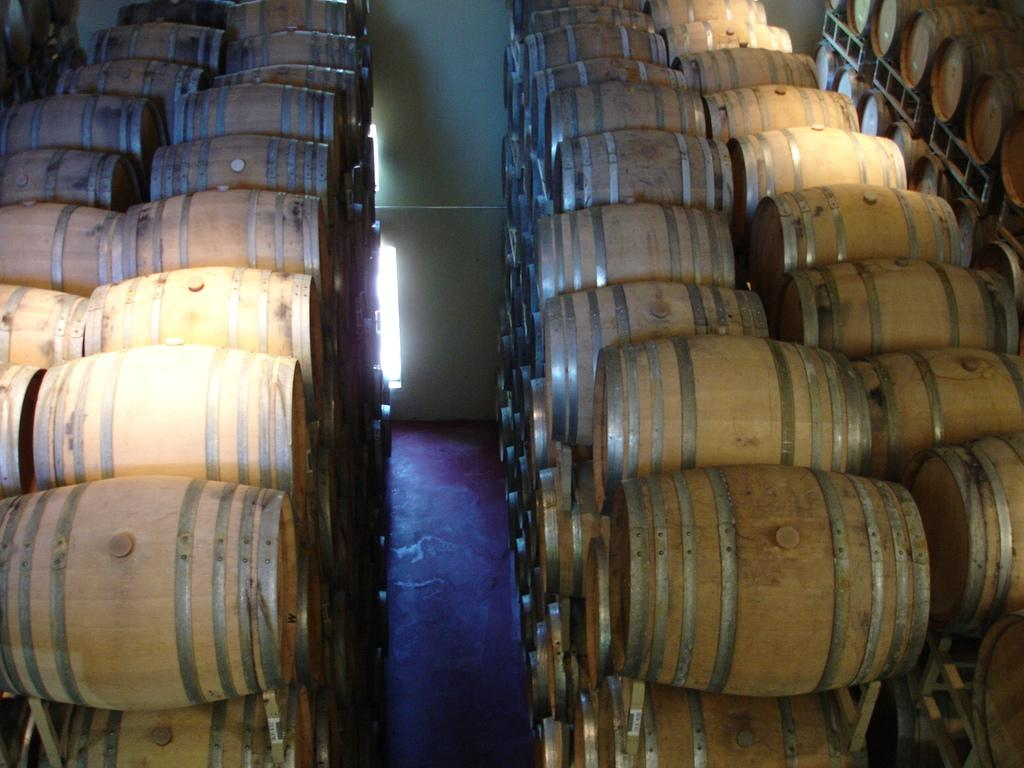What objects are present in large quantities in the image? There are many barrels in the image. What color is the background of the image? The background of the image is white. How many ants can be seen crawling on the barrels in the image? There are no ants present in the image; it only features barrels and a white background. 